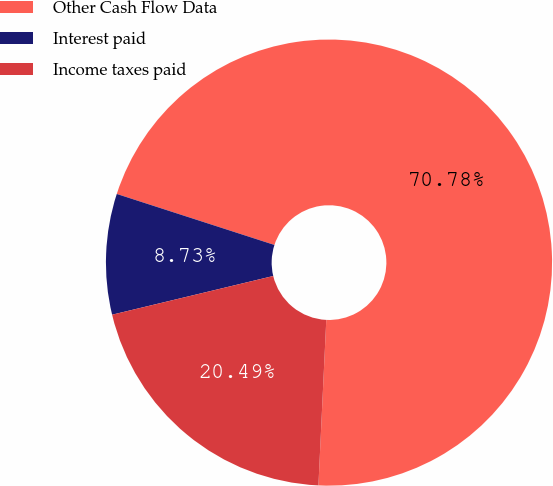Convert chart to OTSL. <chart><loc_0><loc_0><loc_500><loc_500><pie_chart><fcel>Other Cash Flow Data<fcel>Interest paid<fcel>Income taxes paid<nl><fcel>70.77%<fcel>8.73%<fcel>20.49%<nl></chart> 